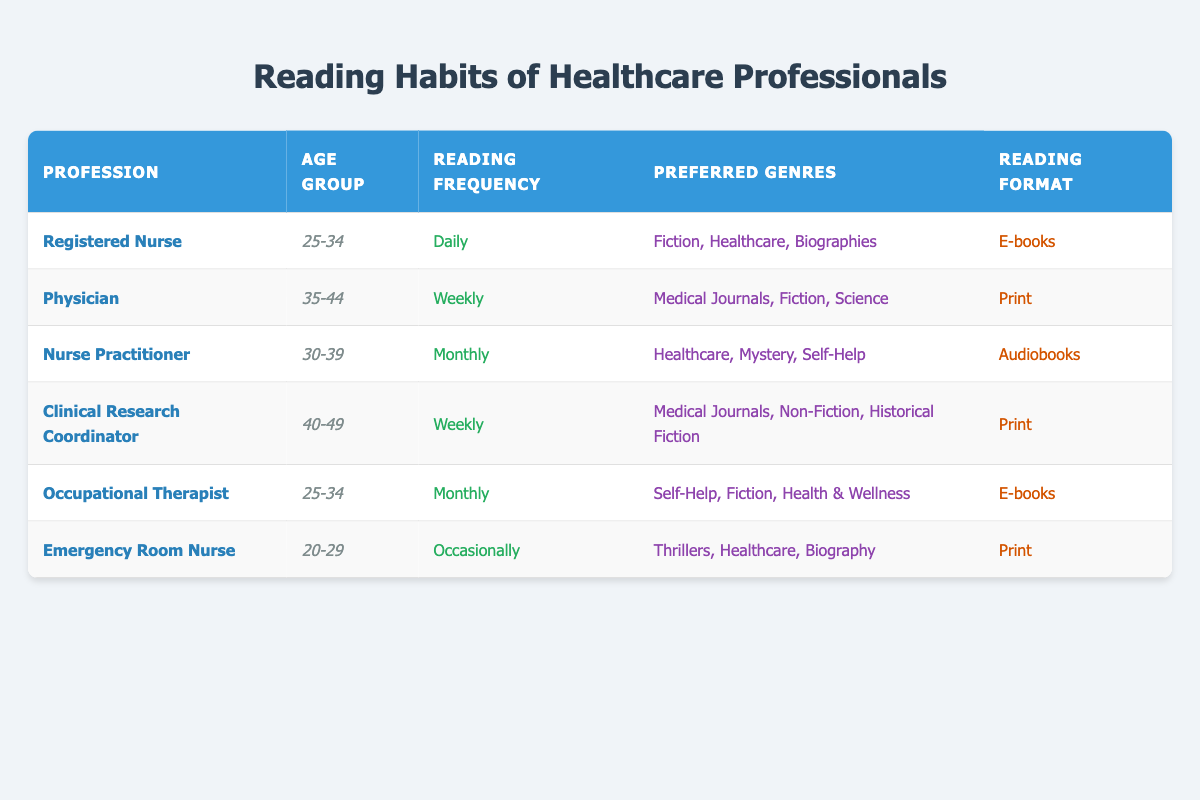What is the reading frequency of Registered Nurses? The table specifies that Registered Nurses read daily.
Answer: Daily How many healthcare professionals prefer Print as their reading format? There are 3 professionals listed who prefer the Print format: Physician, Clinical Research Coordinator, and Emergency Room Nurse.
Answer: 3 Which age group reads Daily most frequently according to the survey? The only professional in the table who reads Daily is a Registered Nurse, who falls into the 25-34 age group.
Answer: 25-34 Do any professionals in the 20-29 age group prefer E-books? No professionals in the 20-29 age group are listed as preferring E-books; the Emergency Room Nurse prefers Print.
Answer: No What are the preferred genres of Nurse Practitioners? According to the table, Nurse Practitioners prefer Healthcare, Mystery, and Self-Help genres.
Answer: Healthcare, Mystery, Self-Help How many professionals read Monthly or more frequently? The reading frequencies that are Monthly or more are Daily (1), Weekly (2), and Monthly (2), totaling 5 professionals.
Answer: 5 Which reading format is most popular among the provided survey results? E-books appear twice (Registered Nurse and Occupational Therapist), while Print and Audiobooks appear three times. Thus, Print is the most popular reading format.
Answer: Print Is there a healthcare profession that prefers Audiobooks? Yes, Nurse Practitioners prefer Audiobooks according to the survey results.
Answer: Yes Which genres are commonly preferred by those who read Weekly? The genres preferred by professionals who read Weekly (Physician and Clinical Research Coordinator) are Medical Journals, Fiction, Science, Non-Fiction, and Historical Fiction.
Answer: Medical Journals, Fiction, Science, Non-Fiction, Historical Fiction 